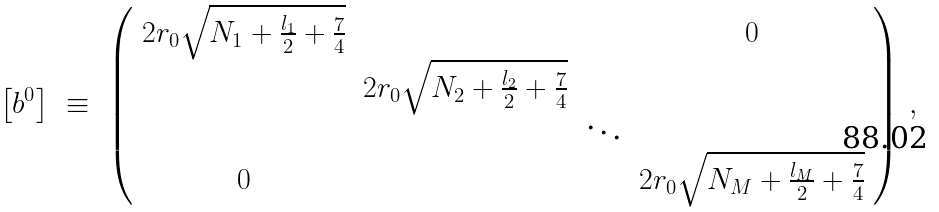<formula> <loc_0><loc_0><loc_500><loc_500>\left [ b ^ { 0 } \right ] \ \equiv \ \left ( \begin{array} { c c c c } 2 r _ { 0 } \sqrt { N _ { 1 } + \frac { l _ { 1 } } { 2 } + \frac { 7 } { 4 } } & & & 0 \\ & 2 r _ { 0 } \sqrt { N _ { 2 } + \frac { l _ { 2 } } { 2 } + \frac { 7 } { 4 } } & & \\ & & \ddots & \\ 0 & & & 2 r _ { 0 } \sqrt { N _ { M } + \frac { l _ { M } } { 2 } + \frac { 7 } { 4 } } \end{array} \right ) \, ,</formula> 